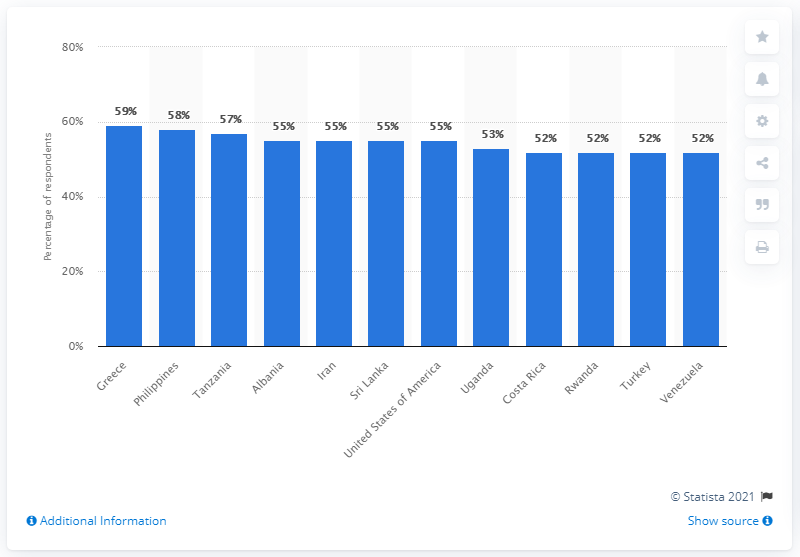Give some essential details in this illustration. According to a survey, 59% of Greeks reported experiencing a lot of stress in the previous day. 